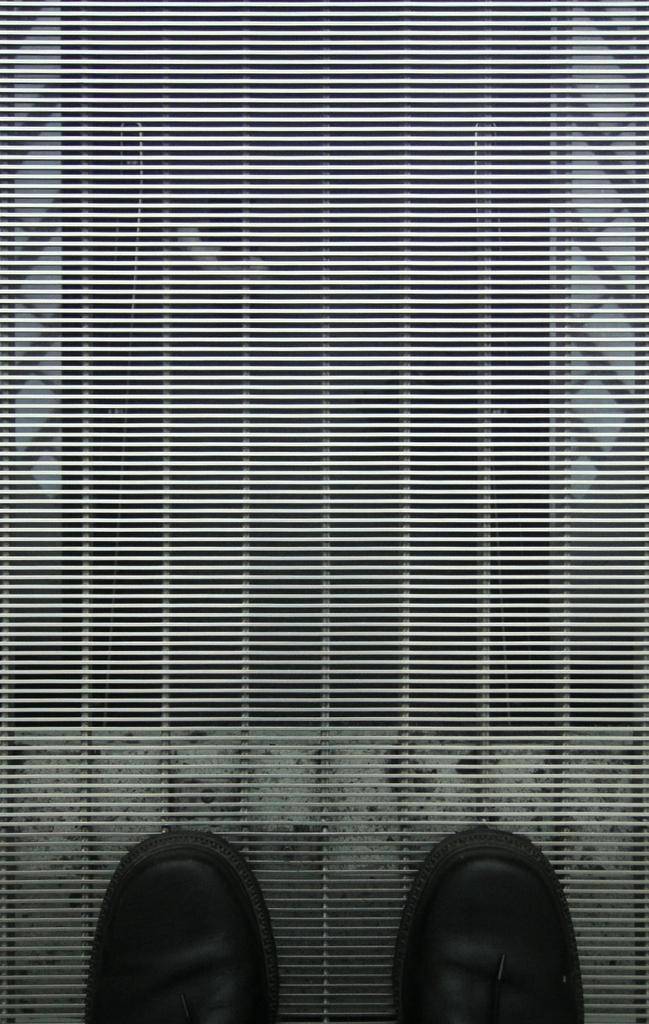How would you summarize this image in a sentence or two? This is a black and white picture, we can see the shoes on the grills. 